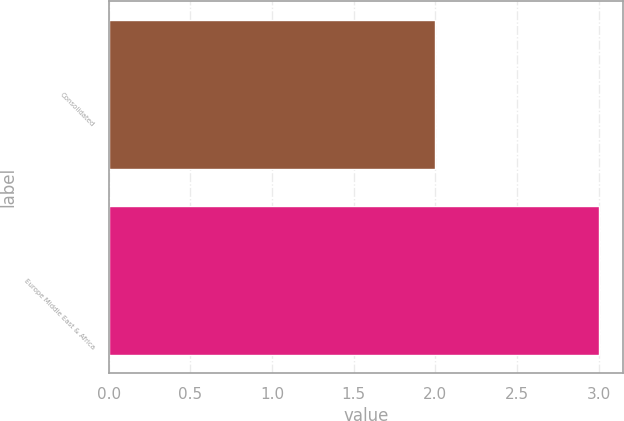<chart> <loc_0><loc_0><loc_500><loc_500><bar_chart><fcel>Consolidated<fcel>Europe Middle East & Africa<nl><fcel>2<fcel>3<nl></chart> 